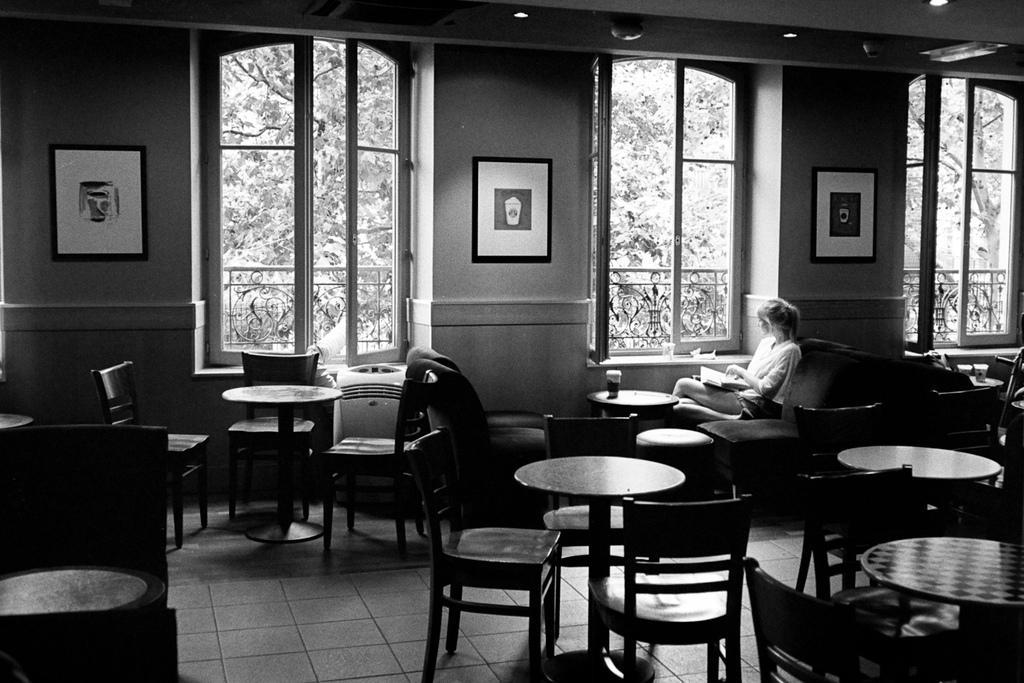Can you describe this image briefly? In this image, there is a person wearing clothes on the chair in front of the table beside the window. There are some tables and chairs in the bottom right of the image. There is a photo frame in the top left and in the top right of the image. There is a window at the top of the image. 